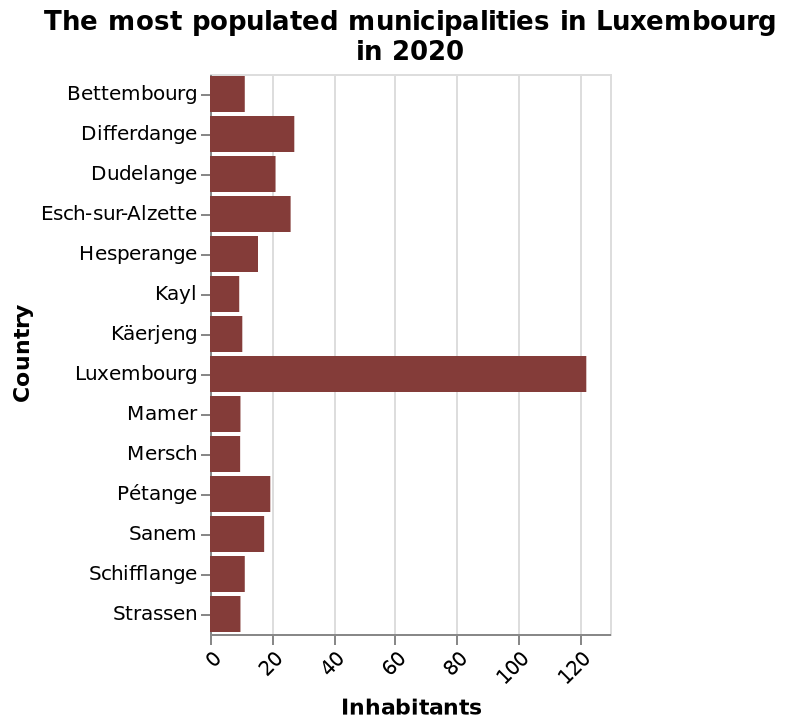<image>
Which municipality is shown at the highest point on the y-axis of the bar chart?  Strassen is shown at the highest point on the y-axis of the bar chart. 